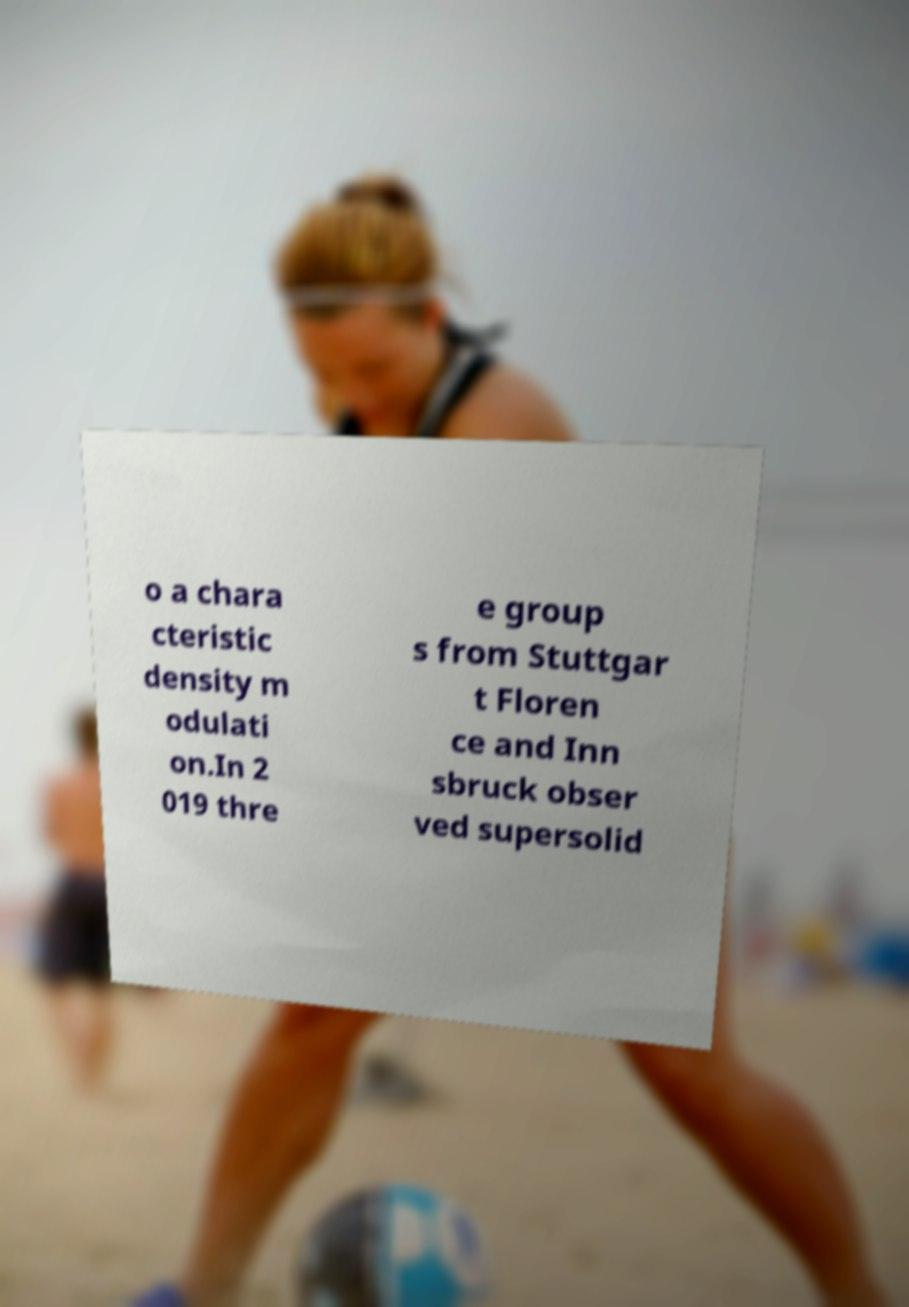I need the written content from this picture converted into text. Can you do that? o a chara cteristic density m odulati on.In 2 019 thre e group s from Stuttgar t Floren ce and Inn sbruck obser ved supersolid 